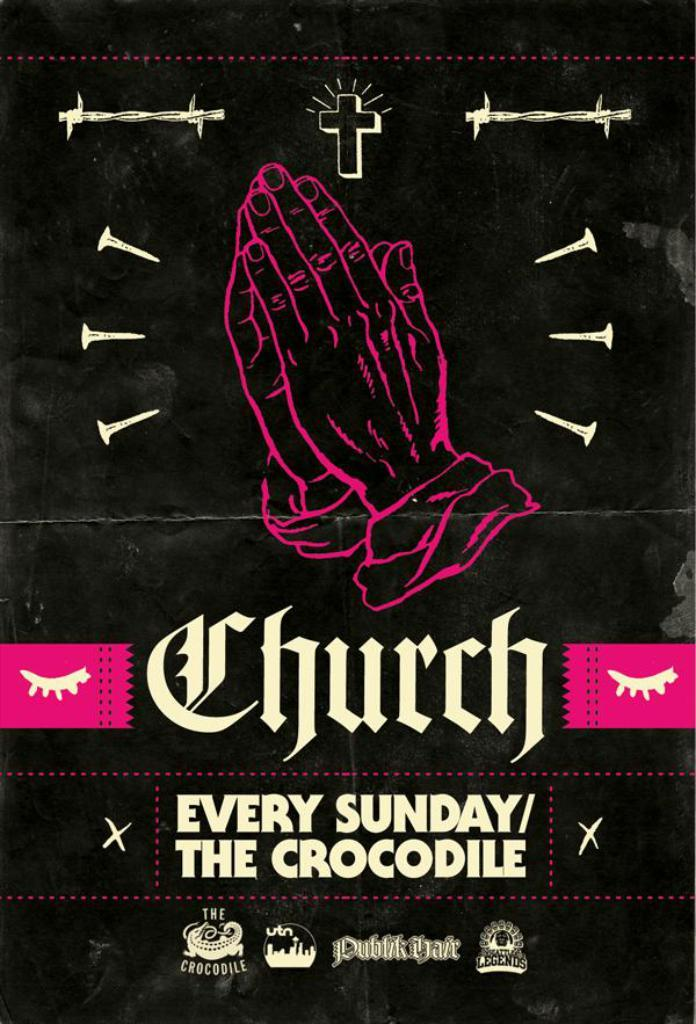<image>
Render a clear and concise summary of the photo. every sunday/the crocodile is advertised on the banner for CHURCH 